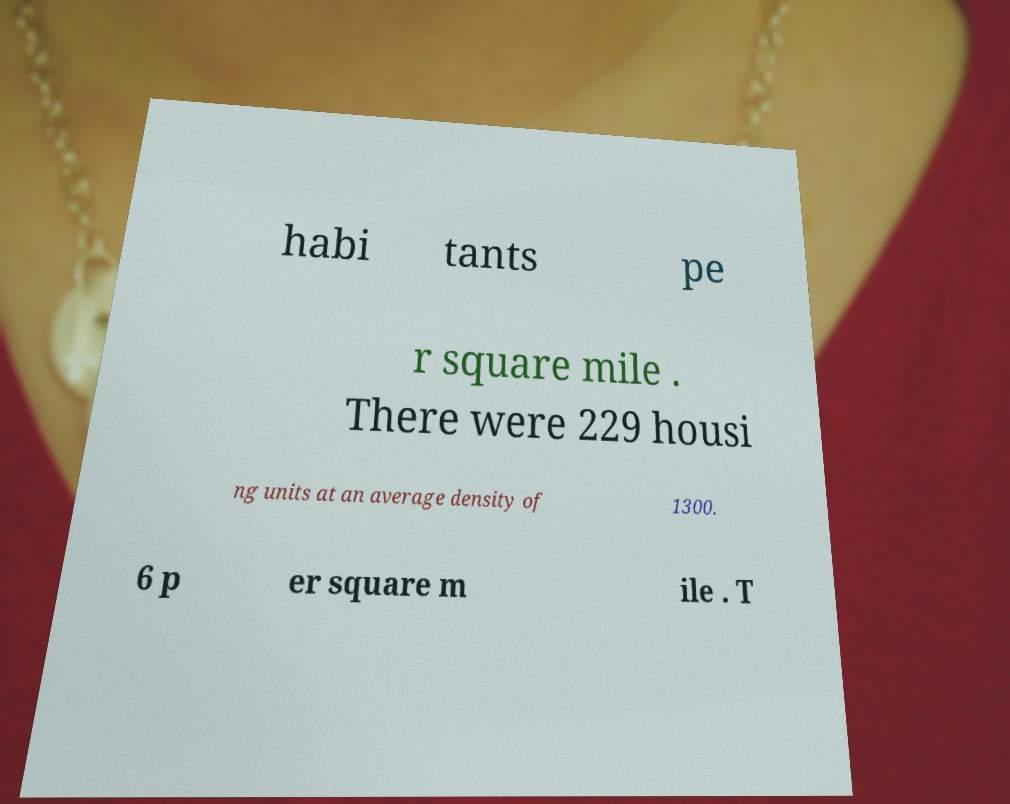For documentation purposes, I need the text within this image transcribed. Could you provide that? habi tants pe r square mile . There were 229 housi ng units at an average density of 1300. 6 p er square m ile . T 